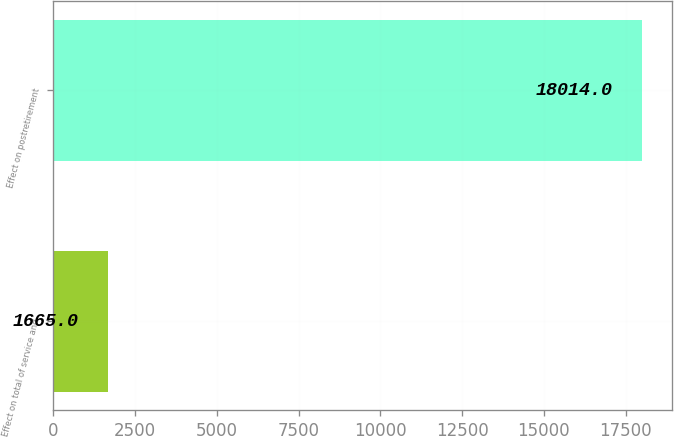<chart> <loc_0><loc_0><loc_500><loc_500><bar_chart><fcel>Effect on total of service and<fcel>Effect on postretirement<nl><fcel>1665<fcel>18014<nl></chart> 